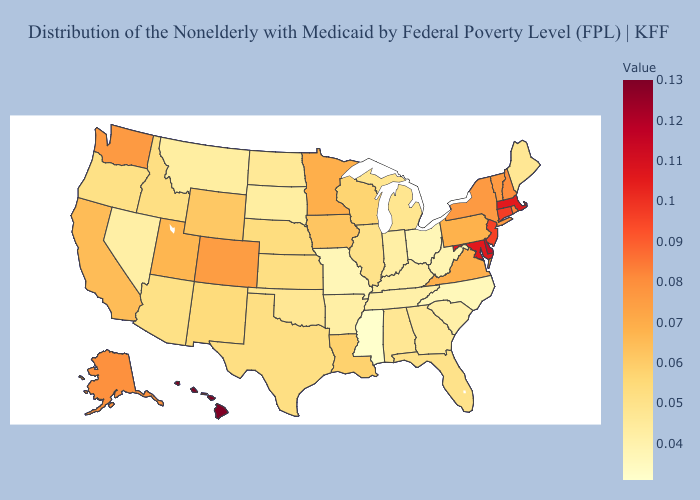Among the states that border South Dakota , does Montana have the lowest value?
Write a very short answer. Yes. Which states hav the highest value in the South?
Quick response, please. Delaware. Among the states that border Mississippi , which have the lowest value?
Answer briefly. Tennessee. Does Indiana have a lower value than Mississippi?
Concise answer only. No. Does New Hampshire have the lowest value in the USA?
Quick response, please. No. Does Nevada have the lowest value in the West?
Short answer required. Yes. Is the legend a continuous bar?
Write a very short answer. Yes. 